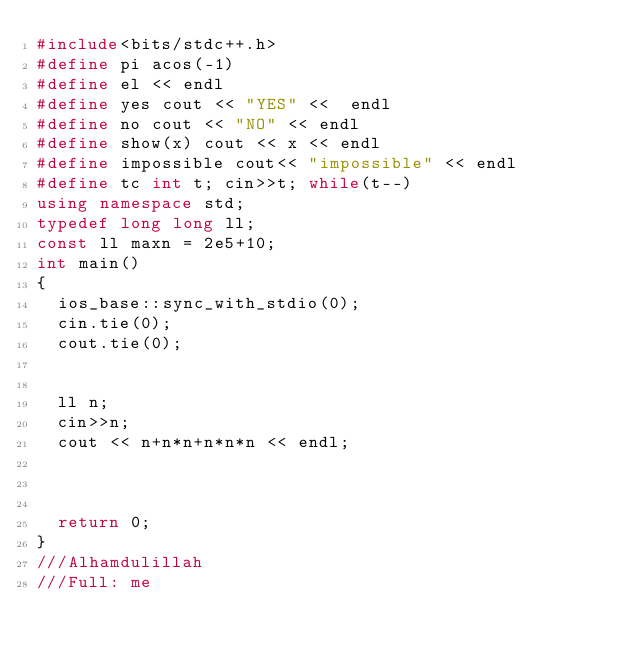Convert code to text. <code><loc_0><loc_0><loc_500><loc_500><_C++_>#include<bits/stdc++.h>
#define pi acos(-1)
#define el << endl
#define yes cout << "YES" <<  endl
#define no cout << "NO" << endl
#define show(x) cout << x << endl
#define impossible cout<< "impossible" << endl
#define tc int t; cin>>t; while(t--)
using namespace std;
typedef long long ll;
const ll maxn = 2e5+10;
int main()
{
	ios_base::sync_with_stdio(0);
	cin.tie(0);
	cout.tie(0);


	ll n;
	cin>>n;
	cout << n+n*n+n*n*n << endl;



	return 0;
}
///Alhamdulillah
///Full: me


</code> 